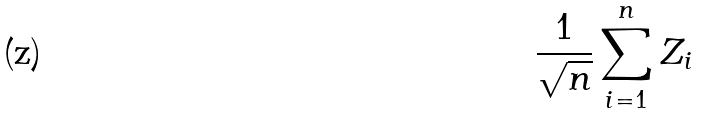Convert formula to latex. <formula><loc_0><loc_0><loc_500><loc_500>\frac { 1 } { \sqrt { n } } \sum _ { i = 1 } ^ { n } Z _ { i }</formula> 